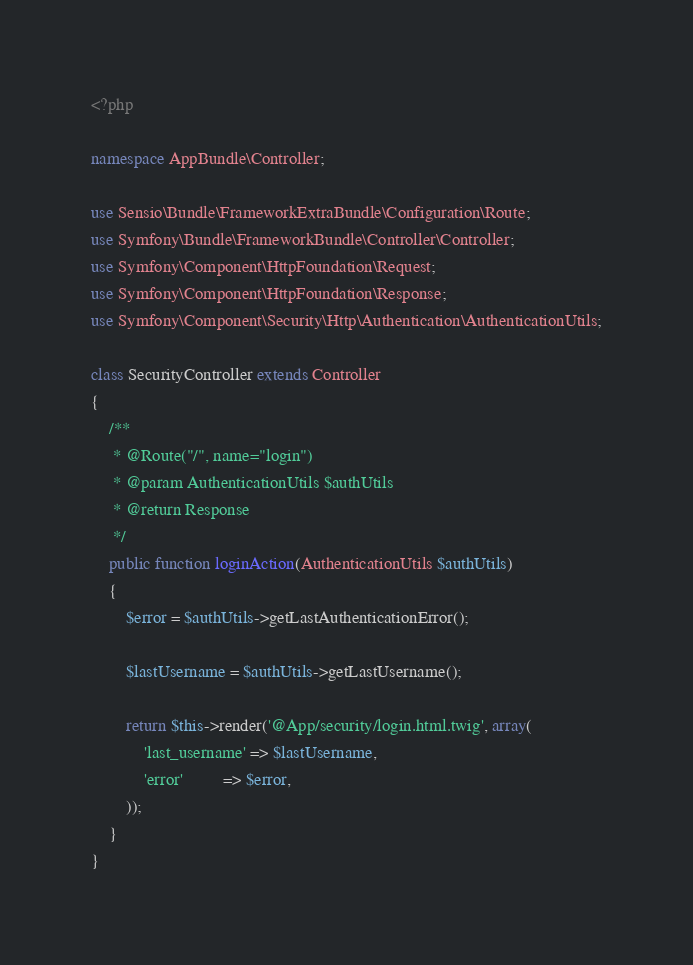<code> <loc_0><loc_0><loc_500><loc_500><_PHP_><?php

namespace AppBundle\Controller;

use Sensio\Bundle\FrameworkExtraBundle\Configuration\Route;
use Symfony\Bundle\FrameworkBundle\Controller\Controller;
use Symfony\Component\HttpFoundation\Request;
use Symfony\Component\HttpFoundation\Response;
use Symfony\Component\Security\Http\Authentication\AuthenticationUtils;

class SecurityController extends Controller
{
    /**
     * @Route("/", name="login")
     * @param AuthenticationUtils $authUtils
     * @return Response
     */
    public function loginAction(AuthenticationUtils $authUtils)
    {
        $error = $authUtils->getLastAuthenticationError();

        $lastUsername = $authUtils->getLastUsername();

        return $this->render('@App/security/login.html.twig', array(
            'last_username' => $lastUsername,
            'error'         => $error,
        ));
    }
}
</code> 